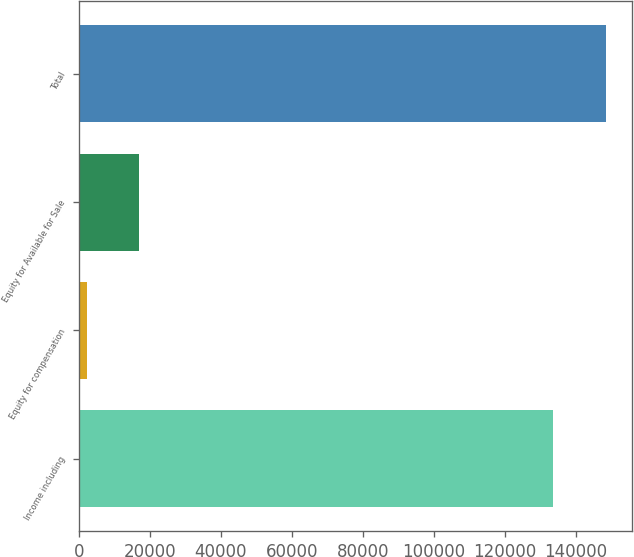Convert chart to OTSL. <chart><loc_0><loc_0><loc_500><loc_500><bar_chart><fcel>Income including<fcel>Equity for compensation<fcel>Equity for Available for Sale<fcel>Total<nl><fcel>133625<fcel>2280<fcel>17020<fcel>148365<nl></chart> 